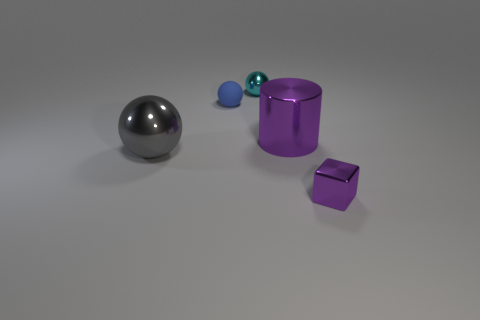Do the cube and the large gray object have the same material?
Your answer should be compact. Yes. There is a thing that is in front of the shiny sphere that is in front of the cylinder; are there any purple metal cylinders in front of it?
Provide a short and direct response. No. What color is the tiny shiny ball?
Keep it short and to the point. Cyan. There is a ball that is the same size as the blue rubber thing; what is its color?
Make the answer very short. Cyan. Do the large shiny object that is on the right side of the small rubber object and the big gray shiny thing have the same shape?
Provide a short and direct response. No. The small metallic object that is to the left of the purple metallic thing that is to the right of the big shiny object that is on the right side of the large gray metallic object is what color?
Ensure brevity in your answer.  Cyan. Are there any purple blocks?
Ensure brevity in your answer.  Yes. What number of other things are there of the same size as the metallic cylinder?
Ensure brevity in your answer.  1. There is a tiny block; is its color the same as the small metallic thing behind the tiny purple object?
Provide a short and direct response. No. How many objects are either purple metal objects or big purple cylinders?
Give a very brief answer. 2. 